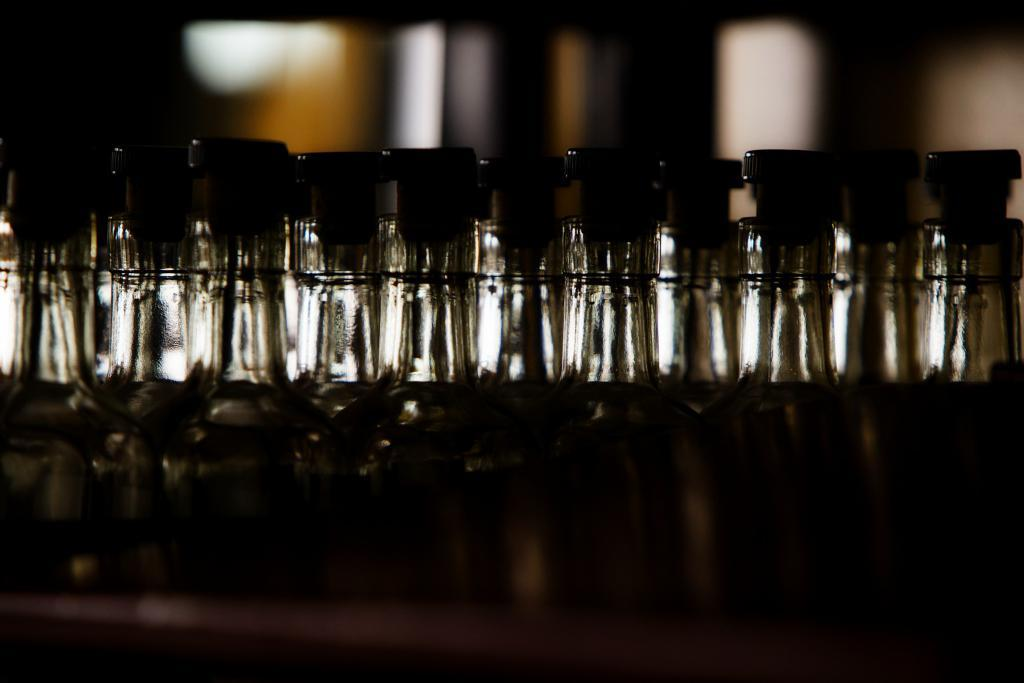What objects can be seen in the image? There are bottles in the image. Can you describe the overall appearance of the image? The image has a dark background or lighting. Where is the bed located in the image? There is no bed present in the image. What type of car can be seen in the front of the image? There is no car present in the image. 